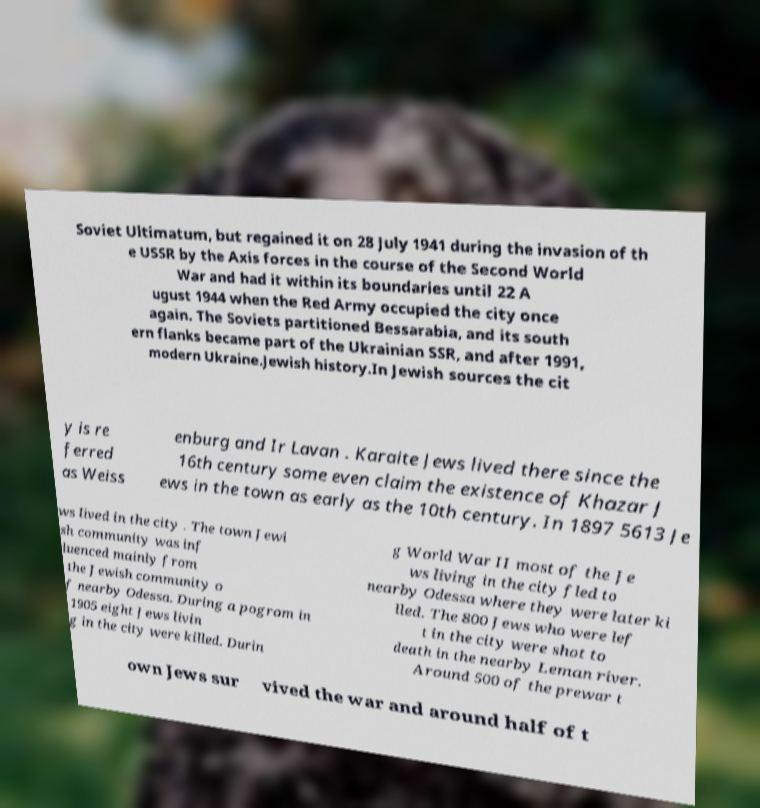Could you extract and type out the text from this image? Soviet Ultimatum, but regained it on 28 July 1941 during the invasion of th e USSR by the Axis forces in the course of the Second World War and had it within its boundaries until 22 A ugust 1944 when the Red Army occupied the city once again. The Soviets partitioned Bessarabia, and its south ern flanks became part of the Ukrainian SSR, and after 1991, modern Ukraine.Jewish history.In Jewish sources the cit y is re ferred as Weiss enburg and Ir Lavan . Karaite Jews lived there since the 16th century some even claim the existence of Khazar J ews in the town as early as the 10th century. In 1897 5613 Je ws lived in the city . The town Jewi sh community was inf luenced mainly from the Jewish community o f nearby Odessa. During a pogrom in 1905 eight Jews livin g in the city were killed. Durin g World War II most of the Je ws living in the city fled to nearby Odessa where they were later ki lled. The 800 Jews who were lef t in the city were shot to death in the nearby Leman river. Around 500 of the prewar t own Jews sur vived the war and around half of t 